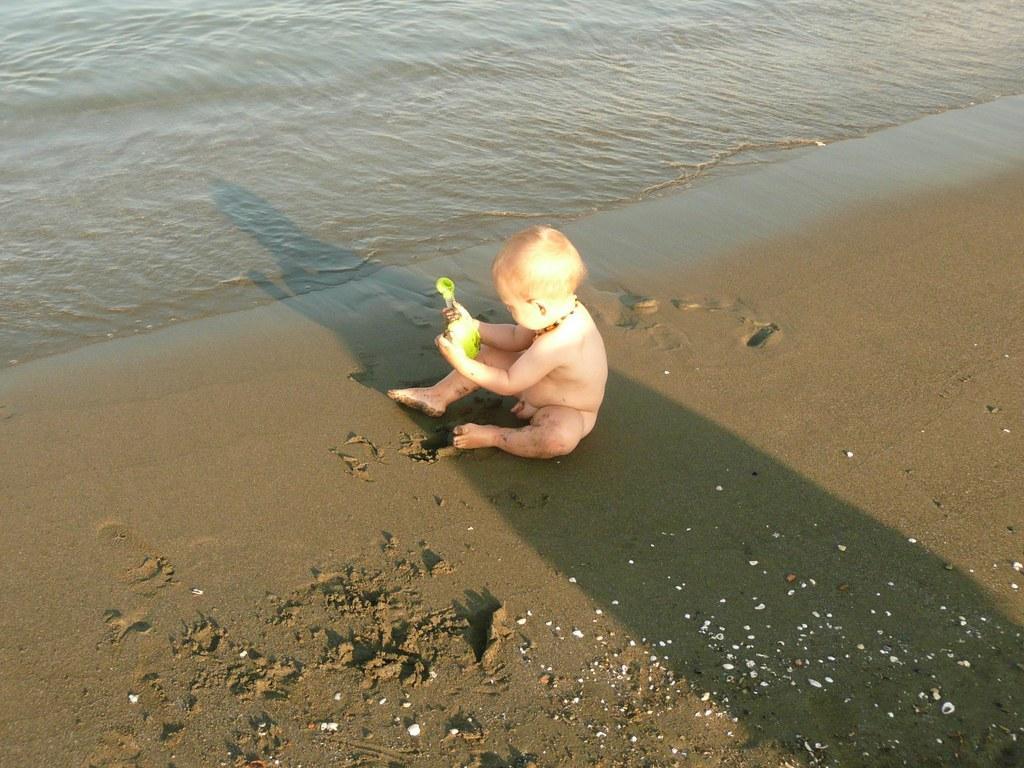Could you give a brief overview of what you see in this image? In this picture there is a small boy in the center of the image, on a muddy floor and there is water at the top side of the image. 